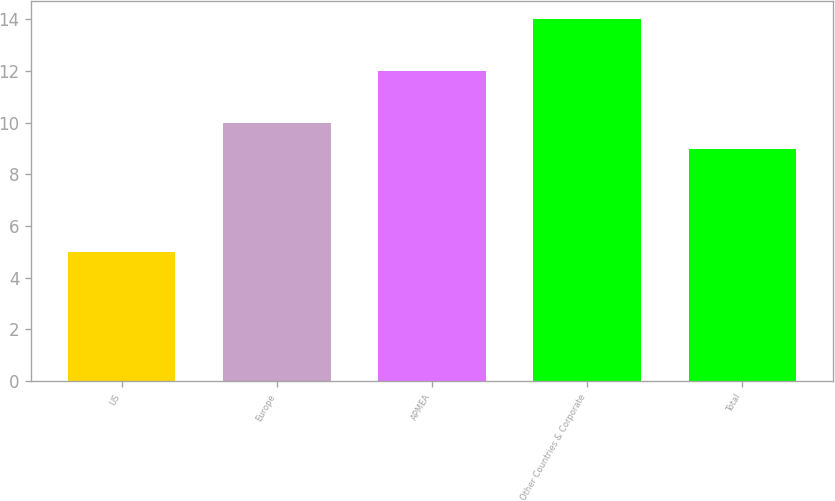Convert chart to OTSL. <chart><loc_0><loc_0><loc_500><loc_500><bar_chart><fcel>US<fcel>Europe<fcel>APMEA<fcel>Other Countries & Corporate<fcel>Total<nl><fcel>5<fcel>10<fcel>12<fcel>14<fcel>9<nl></chart> 